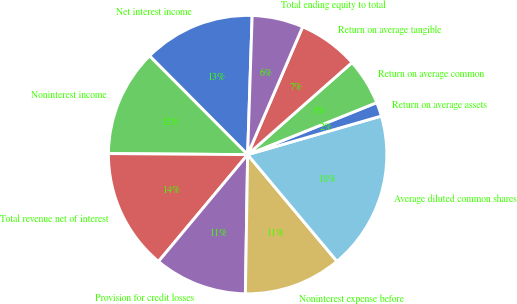Convert chart. <chart><loc_0><loc_0><loc_500><loc_500><pie_chart><fcel>Net interest income<fcel>Noninterest income<fcel>Total revenue net of interest<fcel>Provision for credit losses<fcel>Noninterest expense before<fcel>Average diluted common shares<fcel>Return on average assets<fcel>Return on average common<fcel>Return on average tangible<fcel>Total ending equity to total<nl><fcel>12.97%<fcel>12.43%<fcel>14.05%<fcel>10.81%<fcel>11.35%<fcel>18.38%<fcel>1.62%<fcel>5.41%<fcel>7.03%<fcel>5.95%<nl></chart> 